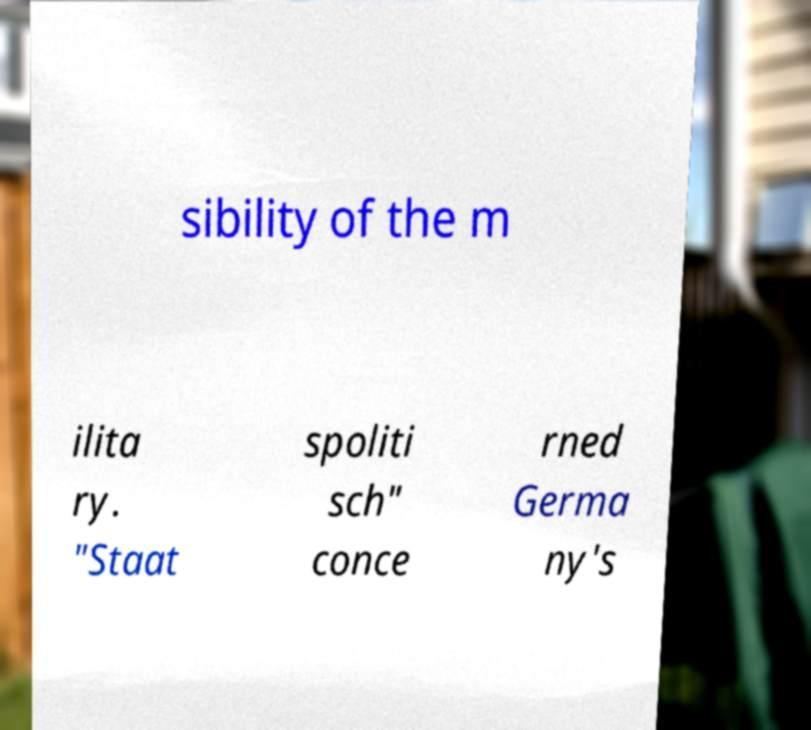I need the written content from this picture converted into text. Can you do that? sibility of the m ilita ry. "Staat spoliti sch" conce rned Germa ny's 